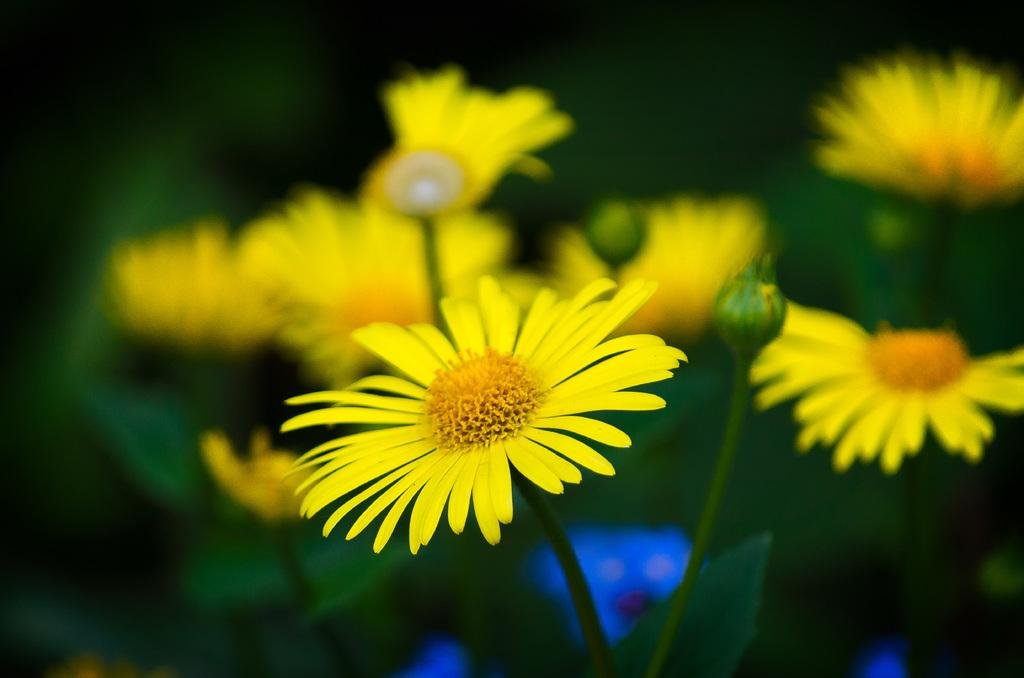What is the main focus of the image? The image is mainly highlighted with flowers. What can be observed about the flowers in the image? Buds and green leaves are visible in the image. How is the background of the image depicted? The background of the image is blurred. What is the opinion of the flowers about the surprise party? The image does not depict flowers having opinions or a surprise party, so this question cannot be answered. 